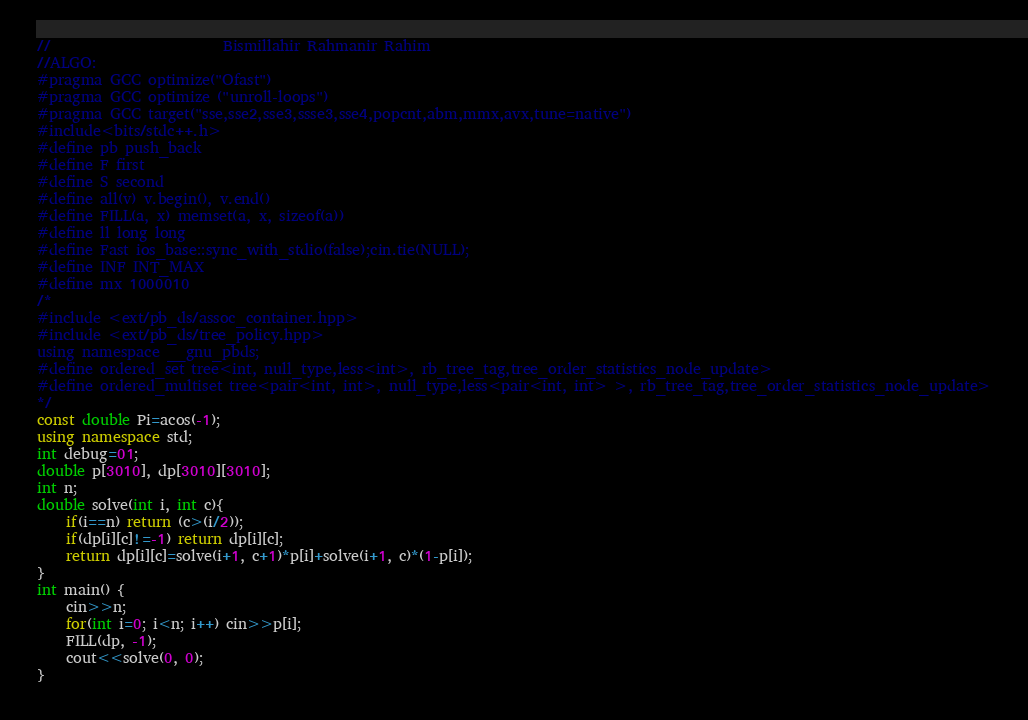Convert code to text. <code><loc_0><loc_0><loc_500><loc_500><_C++_>//                        Bismillahir Rahmanir Rahim
//ALGO:
#pragma GCC optimize("Ofast")
#pragma GCC optimize ("unroll-loops")
#pragma GCC target("sse,sse2,sse3,ssse3,sse4,popcnt,abm,mmx,avx,tune=native")
#include<bits/stdc++.h>
#define pb push_back
#define F first
#define S second
#define all(v) v.begin(), v.end()
#define FILL(a, x) memset(a, x, sizeof(a))
#define ll long long
#define Fast ios_base::sync_with_stdio(false);cin.tie(NULL);
#define INF INT_MAX
#define mx 1000010
/*
#include <ext/pb_ds/assoc_container.hpp>
#include <ext/pb_ds/tree_policy.hpp>
using namespace __gnu_pbds;
#define ordered_set tree<int, null_type,less<int>, rb_tree_tag,tree_order_statistics_node_update>
#define ordered_multiset tree<pair<int, int>, null_type,less<pair<int, int> >, rb_tree_tag,tree_order_statistics_node_update>
*/
const double Pi=acos(-1);
using namespace std;
int debug=01;
double p[3010], dp[3010][3010];
int n;
double solve(int i, int c){
    if(i==n) return (c>(i/2));
    if(dp[i][c]!=-1) return dp[i][c];
    return dp[i][c]=solve(i+1, c+1)*p[i]+solve(i+1, c)*(1-p[i]);
}
int main() {
    cin>>n;
    for(int i=0; i<n; i++) cin>>p[i];
    FILL(dp, -1);
    cout<<solve(0, 0);
}

</code> 